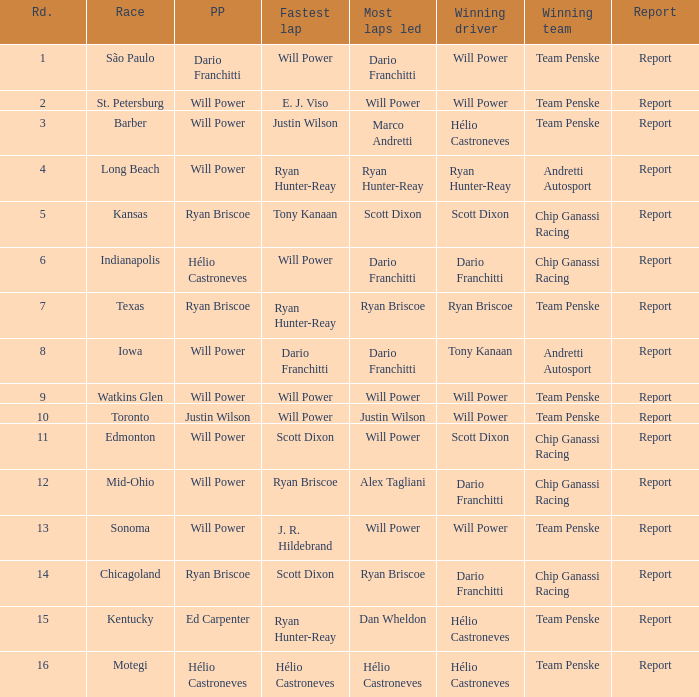Who was on the pole at Chicagoland? Ryan Briscoe. 